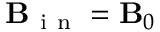Convert formula to latex. <formula><loc_0><loc_0><loc_500><loc_500>B _ { i n } = B _ { 0 }</formula> 